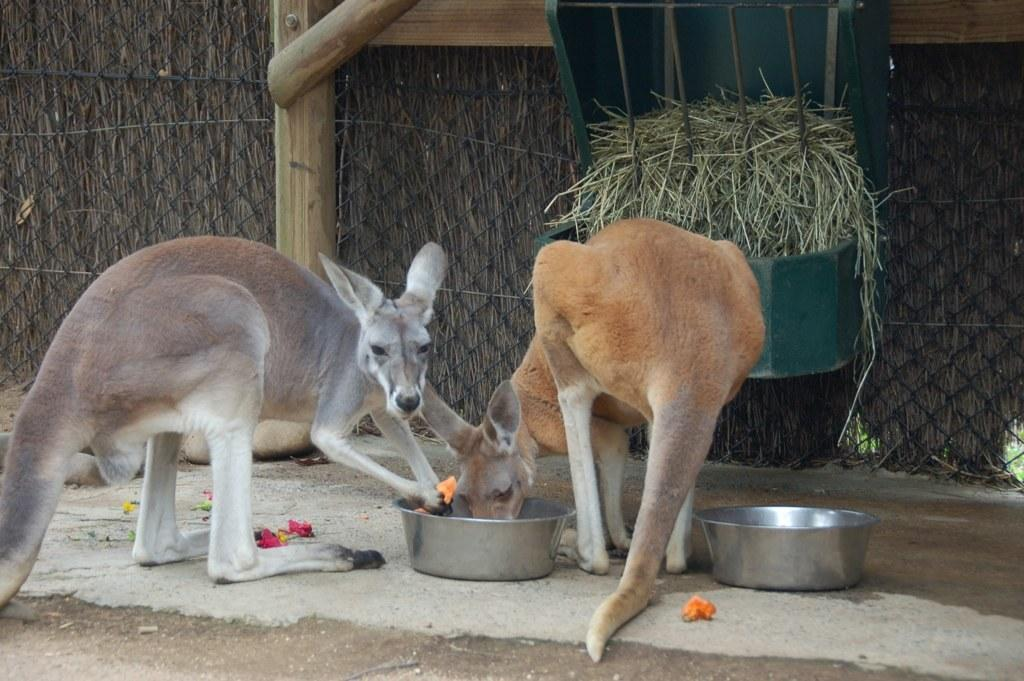What animals are present in the image? There are two kangaroos in the image. What are the kangaroos doing in the image? The kangaroos are eating food from a dish. What else can be seen in the image besides the kangaroos? There is a basket with grass and a mesh visible in the image. What is your sister's favorite way to support the local industry in the image? There is no mention of a sister or local industry in the image, so this question cannot be answered definitively. 